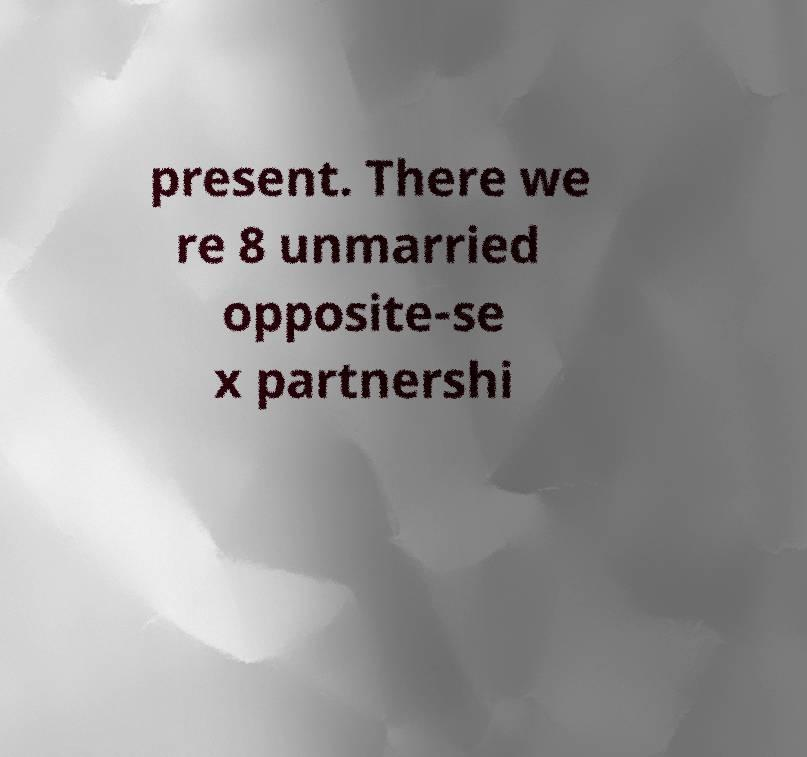There's text embedded in this image that I need extracted. Can you transcribe it verbatim? present. There we re 8 unmarried opposite-se x partnershi 